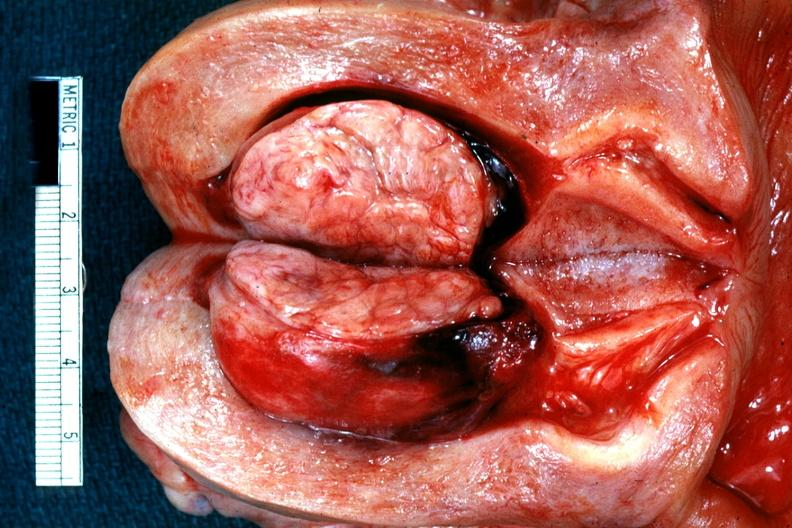what is present?
Answer the question using a single word or phrase. Leiomyoma 